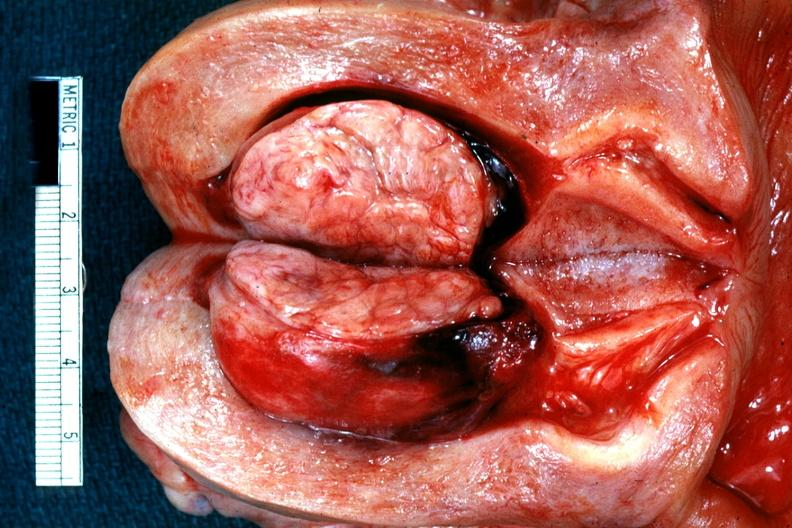what is present?
Answer the question using a single word or phrase. Leiomyoma 